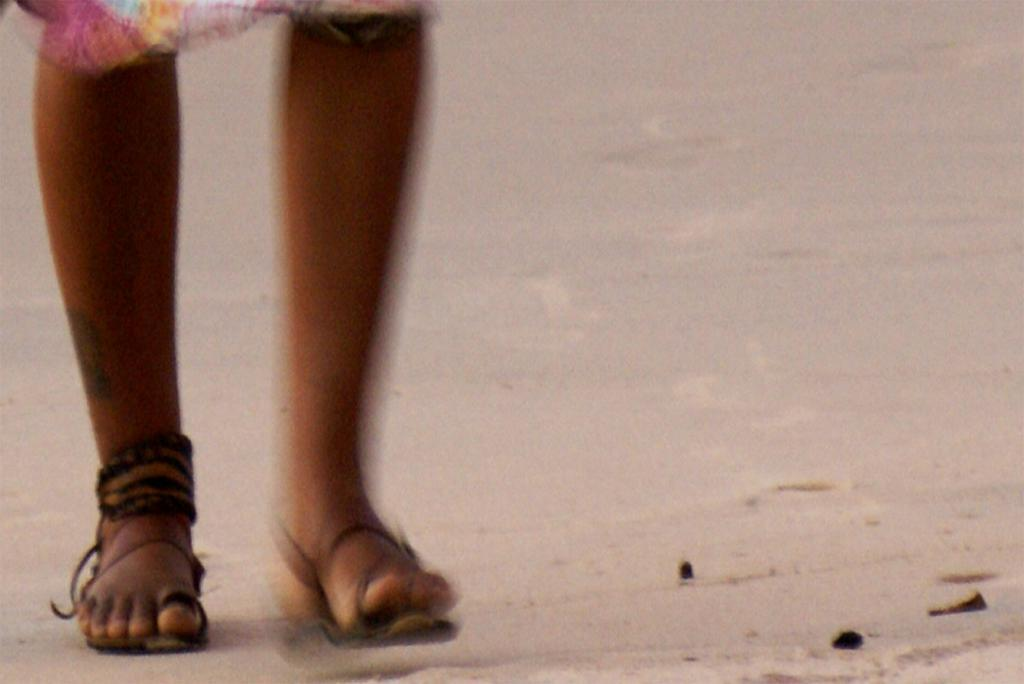What part of a person can be seen in the image? There are legs of a person visible in the image. What type of footwear is the person wearing? The person is wearing footwear. Where are the legs located in the image? The legs are on a pathway. What type of insurance policy does the person have for their orange in the image? There is no orange or mention of insurance in the image. 